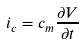Convert formula to latex. <formula><loc_0><loc_0><loc_500><loc_500>i _ { c } = c _ { m } \frac { \partial V } { \partial t }</formula> 